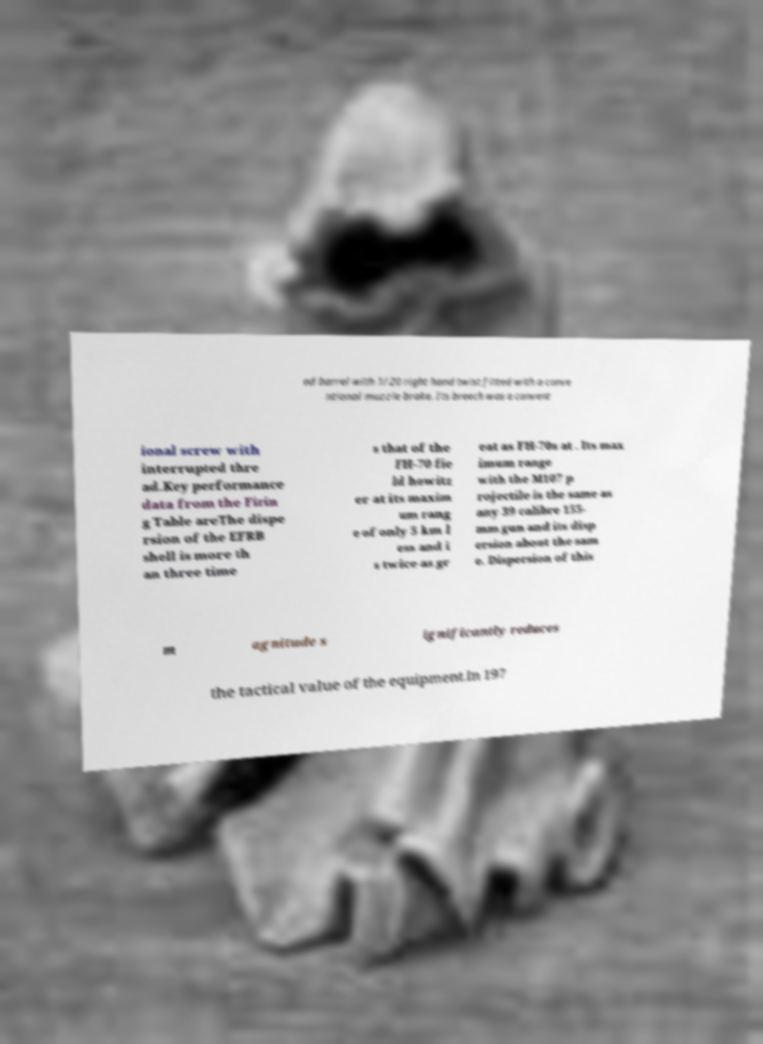Please identify and transcribe the text found in this image. ed barrel with 1/20 right hand twist fitted with a conve ntional muzzle brake. Its breech was a convent ional screw with interrupted thre ad.Key performance data from the Firin g Table areThe dispe rsion of the EFRB shell is more th an three time s that of the FH-70 fie ld howitz er at its maxim um rang e of only 5 km l ess and i s twice as gr eat as FH-70s at . Its max imum range with the M107 p rojectile is the same as any 39 calibre 155- mm gun and its disp ersion about the sam e. Dispersion of this m agnitude s ignificantly reduces the tactical value of the equipment.In 197 